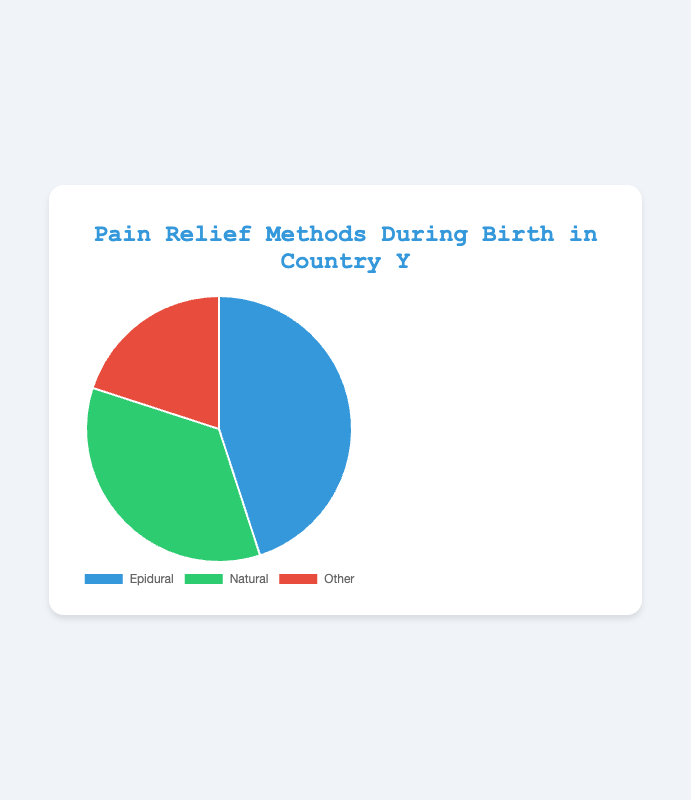What percentage of births used Epidural for pain relief in Country Y? The figure shows a pie chart with the breakdown of pain relief methods. Epidural constitutes 45% of the chart.
Answer: 45% Which pain relief method is the least used in Country Y? The pie chart shows three methods: Epidural (45%), Natural (35%), and Other (20%). The method with the lowest percentage is Other.
Answer: Other How much greater is the use of Epidural compared to Natural methods? Epidural is at 45% and Natural is at 35%. Subtract Natural's percentage (35%) from Epidural's percentage (45%). 45% - 35% = 10%.
Answer: 10% What is the combined percentage of non-epidural methods? The non-epidural methods are Natural and Other. Combine their percentages: Natural (35%) + Other (20%) = 55%.
Answer: 55% If 1000 births happened in Country Y, how many of them used 'Other' methods for pain relief? 'Other' constitutes 20% of the pie chart. Calculate 20% of 1000: 0.20 * 1000 = 200.
Answer: 200 Is the percentage of births using Natural methods for pain relief greater than those using Other methods? Yes, the percentage for Natural (35%) is greater than for Other (20%).
Answer: Yes What is the ratio of births using Epidural to those using Other methods? The percentages are 45% for Epidural and 20% for Other. The ratio is 45:20, which simplifies to 9:4.
Answer: 9:4 Which segment of the pie chart is colored green? Based on the visual attributes described, the Natural method is colored green.
Answer: Natural How much more common are Epidurals compared to Other methods? Epidurals are at 45% while Other methods are at 20%. Subtract Other's percentage (20%) from Epidural's percentage (45%). 45% - 20% = 25%.
Answer: 25% If the percentage of Natural births were to increase by 5%, what would the new percentage be and what would the new combined percentage for non-epidural methods be? Increasing Natural methods by 5% gives you 35% + 5% = 40%. The new combined percentage for non-epidural methods would be 40% (Natural) + 20% (Other) = 60%.
Answer: 40%, 60% 